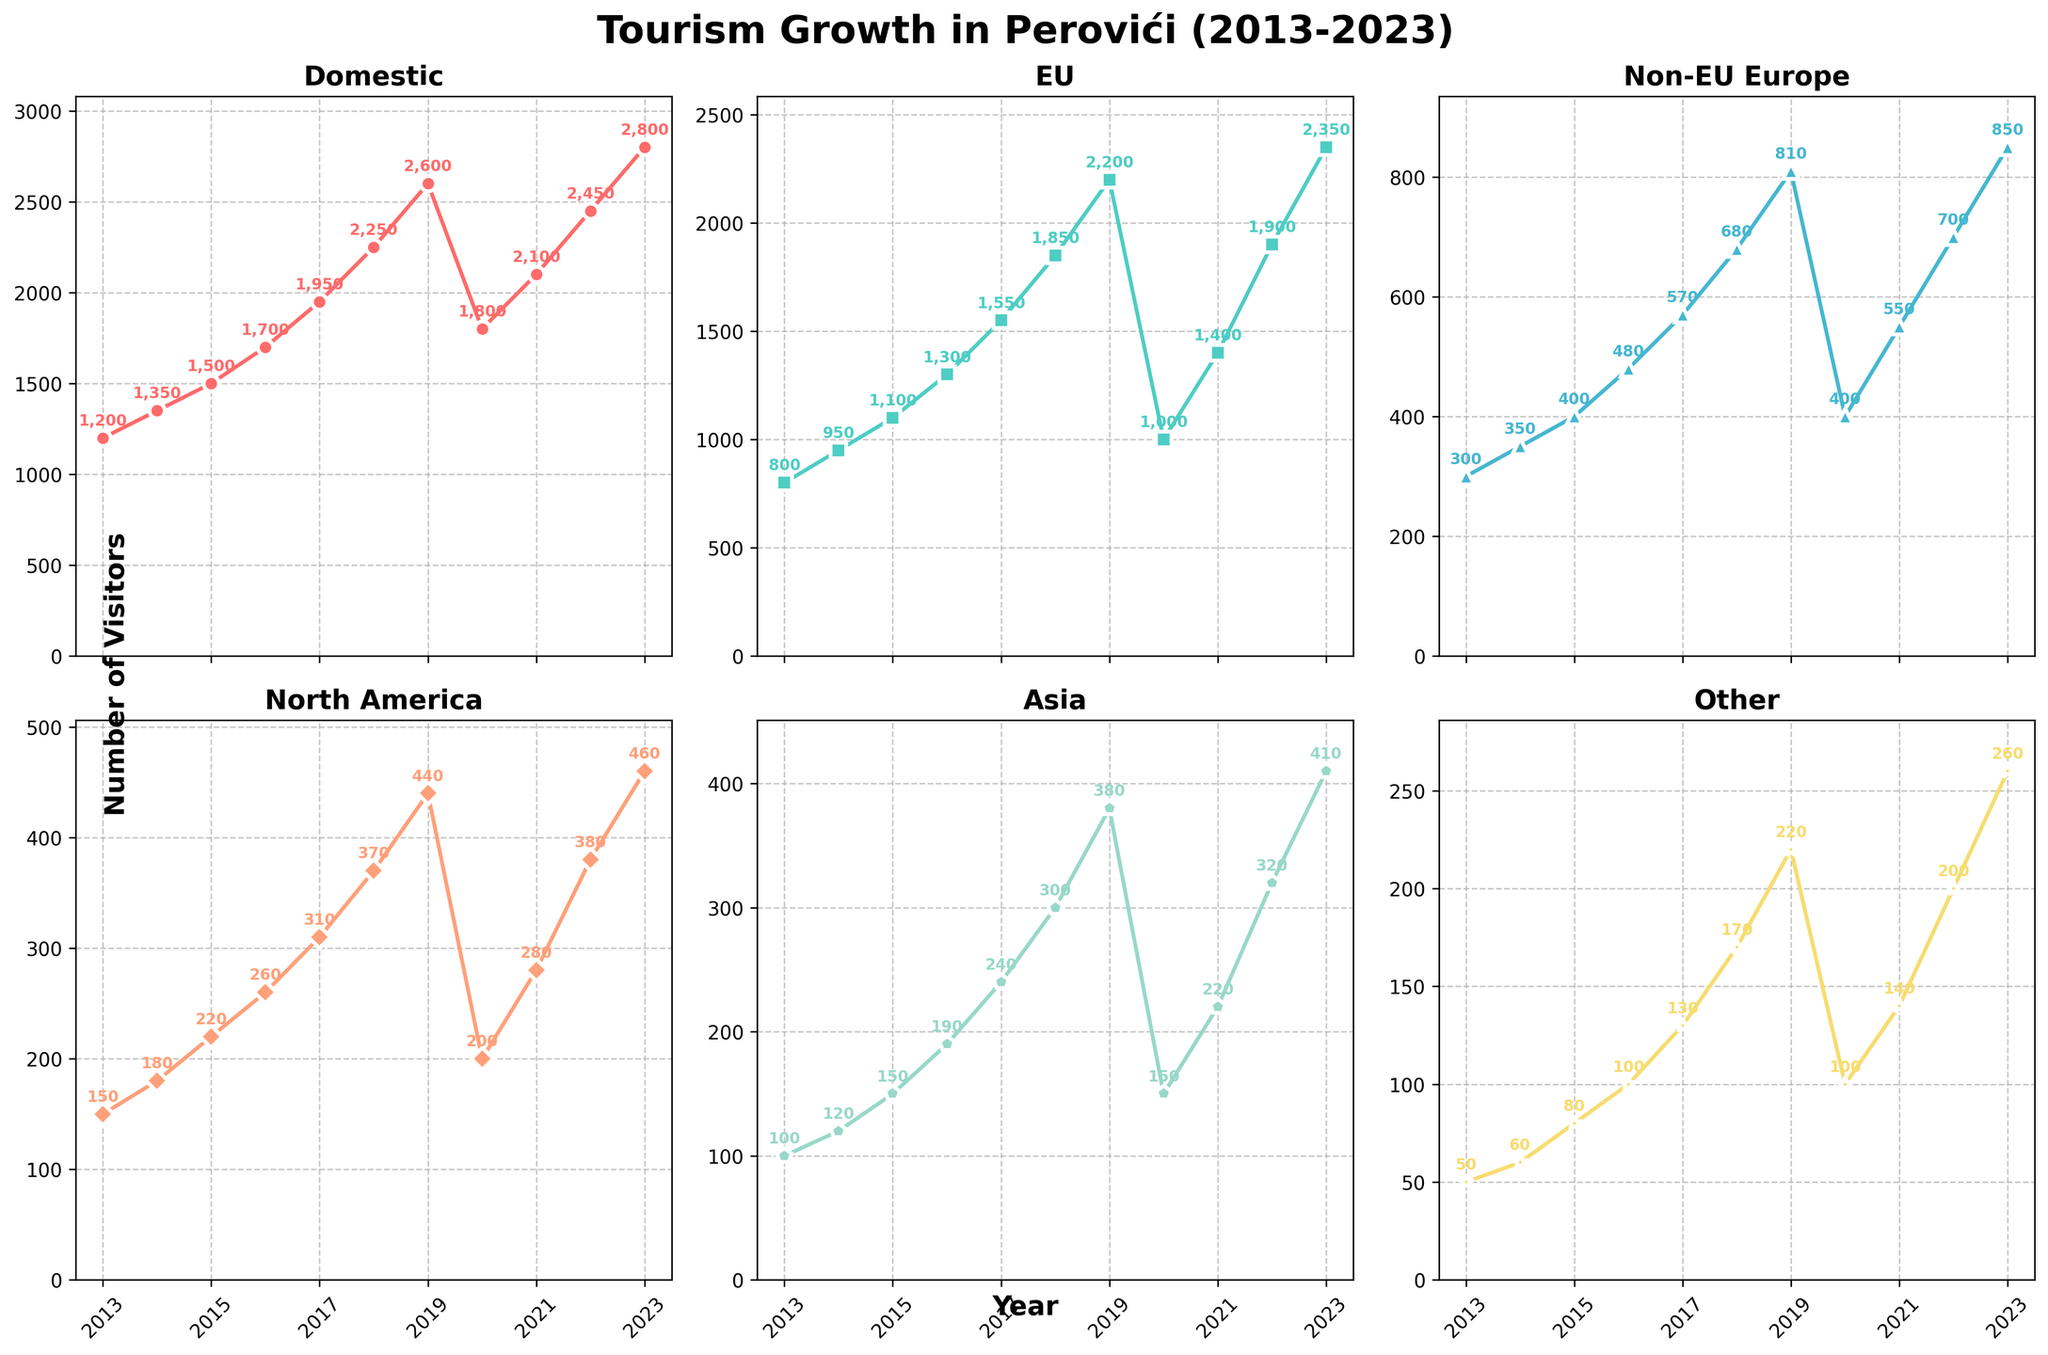What year did Perovići see the lowest number of total visitors? Sum all visitor categories for each year (Domestic + EU + Non-EU Europe + North America + Asia + Other), identify the year with the lowest sum. For 2020: 1800 + 1000 + 400 + 200 + 150 + 100 = 3650, which is the lowest
Answer: 2020 Which visitor origin saw the most significant growth from 2013 to 2023? Calculate the difference in numbers from 2013 to 2023 for each category. Domestic: 2800 - 1200 = 1600, EU: 2350 - 800 = 1550, Non-EU Europe: 850 - 300 = 550, North America: 460 - 150 = 310, Asia: 410 - 100 = 310, Other: 260 - 50 = 210. Domestic has the most significant growth
Answer: Domestic How does the number of North American visitors in 2023 compare to 2018? Compare values for North American visitors in the respective years: 460 in 2023 and 370 in 2018. 460 is greater than 370
Answer: Greater What's the average number of EU visitors per year over the entire period? Sum of all EU visitors (sum of values in the EU column) divided by the count of years. (800 + 950 + 1100 + 1300 + 1550 + 1850 + 2200 + 1000 + 1400 + 1900 + 2350)/11 = 15609 / 11 = 1419
Answer: 1419 Which visitor category has the highest max value across all years? Compare the maximum value for each category: Domestic: 2800, EU: 2350, Non-EU Europe: 850, North America: 460, Asia: 410, Other: 260. Domestic has the highest max value
Answer: Domestic In which year did the number of Asian visitors surpass the 200 mark for the first time? Identify the first year where Asian visitors > 200. For 2017, Asian visitors = 240, marking the first surpass of 200
Answer: 2017 By how much did the number of non-EU European visitors in 2023 exceed those in 2013? Subtract the number of non-EU European visitors in 2013 from the number in 2023: 850 - 300 = 550
Answer: 550 